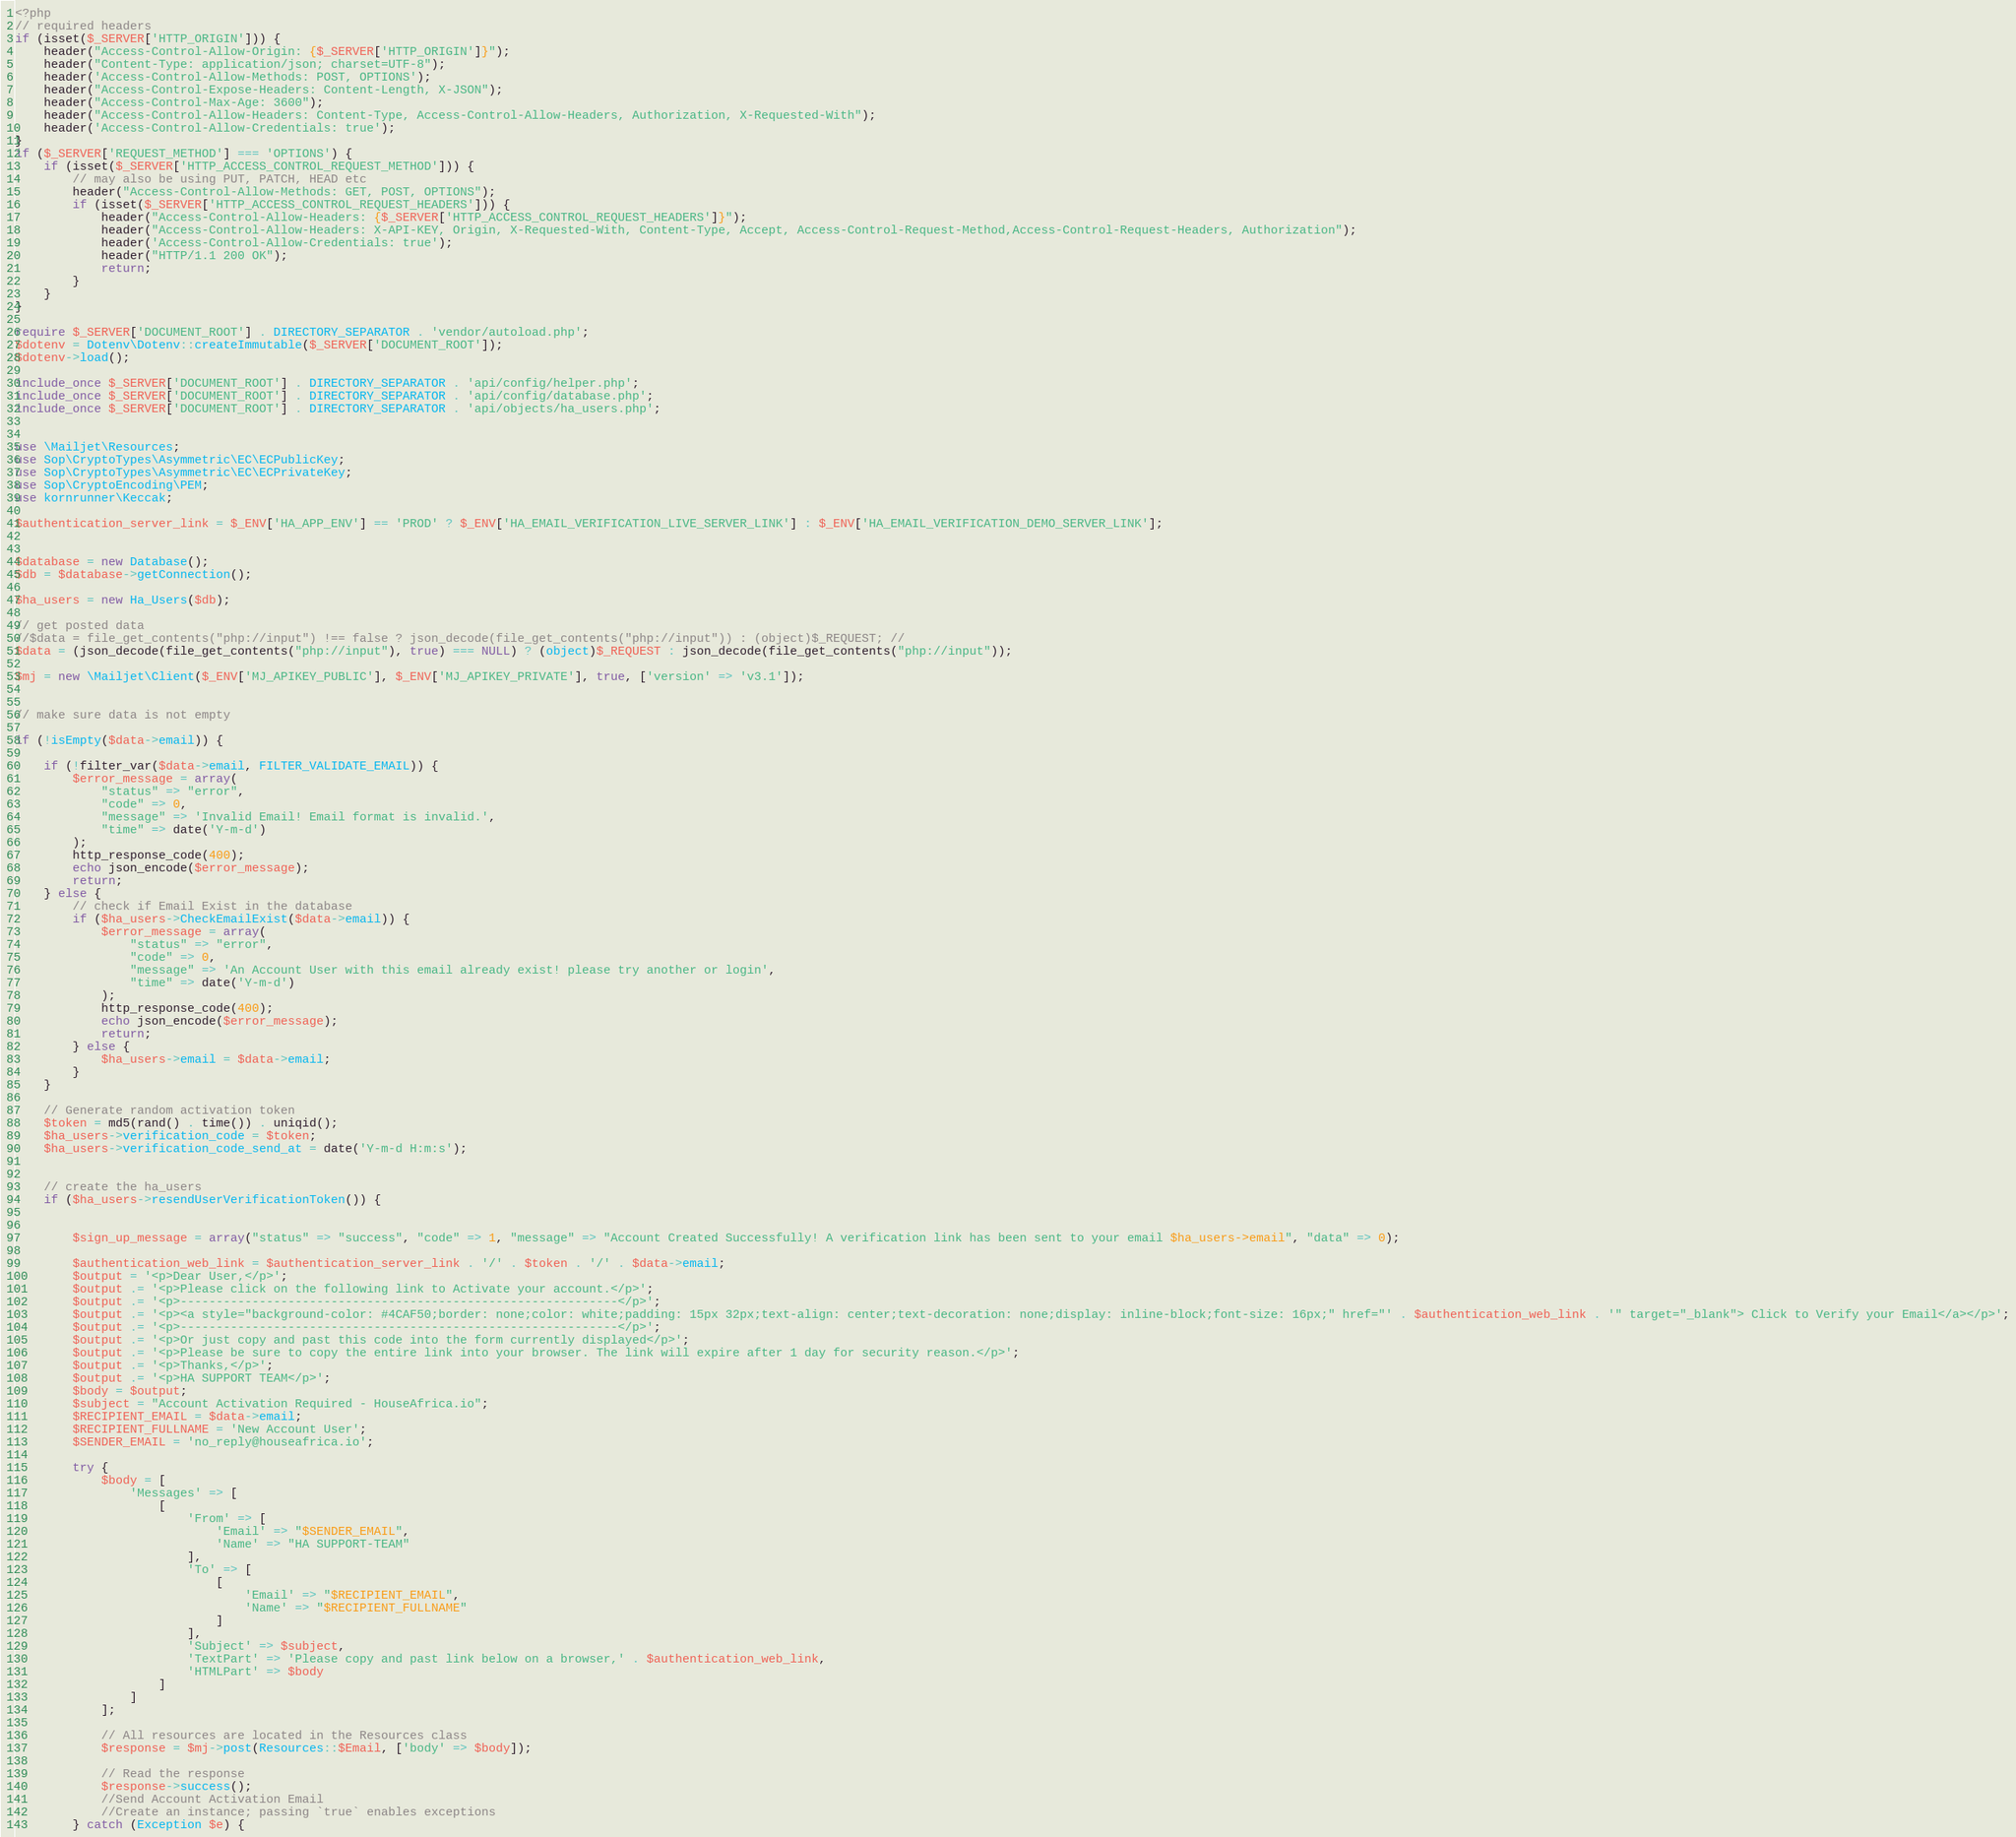Convert code to text. <code><loc_0><loc_0><loc_500><loc_500><_PHP_><?php
// required headers
if (isset($_SERVER['HTTP_ORIGIN'])) {
    header("Access-Control-Allow-Origin: {$_SERVER['HTTP_ORIGIN']}");
    header("Content-Type: application/json; charset=UTF-8");
    header('Access-Control-Allow-Methods: POST, OPTIONS');
    header("Access-Control-Expose-Headers: Content-Length, X-JSON");
    header("Access-Control-Max-Age: 3600");
    header("Access-Control-Allow-Headers: Content-Type, Access-Control-Allow-Headers, Authorization, X-Requested-With");
    header('Access-Control-Allow-Credentials: true');
}
if ($_SERVER['REQUEST_METHOD'] === 'OPTIONS') {
    if (isset($_SERVER['HTTP_ACCESS_CONTROL_REQUEST_METHOD'])) {
        // may also be using PUT, PATCH, HEAD etc
        header("Access-Control-Allow-Methods: GET, POST, OPTIONS");
        if (isset($_SERVER['HTTP_ACCESS_CONTROL_REQUEST_HEADERS'])) {
            header("Access-Control-Allow-Headers: {$_SERVER['HTTP_ACCESS_CONTROL_REQUEST_HEADERS']}");
            header("Access-Control-Allow-Headers: X-API-KEY, Origin, X-Requested-With, Content-Type, Accept, Access-Control-Request-Method,Access-Control-Request-Headers, Authorization");
            header('Access-Control-Allow-Credentials: true');
            header("HTTP/1.1 200 OK");
            return;
        }
    }
}

require $_SERVER['DOCUMENT_ROOT'] . DIRECTORY_SEPARATOR . 'vendor/autoload.php';
$dotenv = Dotenv\Dotenv::createImmutable($_SERVER['DOCUMENT_ROOT']);
$dotenv->load();

include_once $_SERVER['DOCUMENT_ROOT'] . DIRECTORY_SEPARATOR . 'api/config/helper.php';
include_once $_SERVER['DOCUMENT_ROOT'] . DIRECTORY_SEPARATOR . 'api/config/database.php';
include_once $_SERVER['DOCUMENT_ROOT'] . DIRECTORY_SEPARATOR . 'api/objects/ha_users.php';


use \Mailjet\Resources;
use Sop\CryptoTypes\Asymmetric\EC\ECPublicKey;
use Sop\CryptoTypes\Asymmetric\EC\ECPrivateKey;
use Sop\CryptoEncoding\PEM;
use kornrunner\Keccak;

$authentication_server_link = $_ENV['HA_APP_ENV'] == 'PROD' ? $_ENV['HA_EMAIL_VERIFICATION_LIVE_SERVER_LINK'] : $_ENV['HA_EMAIL_VERIFICATION_DEMO_SERVER_LINK'];


$database = new Database();
$db = $database->getConnection();

$ha_users = new Ha_Users($db);

// get posted data
//$data = file_get_contents("php://input") !== false ? json_decode(file_get_contents("php://input")) : (object)$_REQUEST; //
$data = (json_decode(file_get_contents("php://input"), true) === NULL) ? (object)$_REQUEST : json_decode(file_get_contents("php://input"));

$mj = new \Mailjet\Client($_ENV['MJ_APIKEY_PUBLIC'], $_ENV['MJ_APIKEY_PRIVATE'], true, ['version' => 'v3.1']);


// make sure data is not empty

if (!isEmpty($data->email)) {

    if (!filter_var($data->email, FILTER_VALIDATE_EMAIL)) {
        $error_message = array(
            "status" => "error",
            "code" => 0,
            "message" => 'Invalid Email! Email format is invalid.',
            "time" => date('Y-m-d')
        );
        http_response_code(400);
        echo json_encode($error_message);
        return;
    } else {
        // check if Email Exist in the database
        if ($ha_users->CheckEmailExist($data->email)) {
            $error_message = array(
                "status" => "error",
                "code" => 0,
                "message" => 'An Account User with this email already exist! please try another or login',
                "time" => date('Y-m-d')
            );
            http_response_code(400);
            echo json_encode($error_message);
            return;
        } else {
            $ha_users->email = $data->email;
        }
    }

    // Generate random activation token
    $token = md5(rand() . time()) . uniqid();
    $ha_users->verification_code = $token;
    $ha_users->verification_code_send_at = date('Y-m-d H:m:s');


    // create the ha_users
    if ($ha_users->resendUserVerificationToken()) {


        $sign_up_message = array("status" => "success", "code" => 1, "message" => "Account Created Successfully! A verification link has been sent to your email $ha_users->email", "data" => 0);

        $authentication_web_link = $authentication_server_link . '/' . $token . '/' . $data->email;
        $output = '<p>Dear User,</p>';
        $output .= '<p>Please click on the following link to Activate your account.</p>';
        $output .= '<p>-------------------------------------------------------------</p>';
        $output .= '<p><a style="background-color: #4CAF50;border: none;color: white;padding: 15px 32px;text-align: center;text-decoration: none;display: inline-block;font-size: 16px;" href="' . $authentication_web_link . '" target="_blank"> Click to Verify your Email</a></p>';
        $output .= '<p>-------------------------------------------------------------</p>';
        $output .= '<p>Or just copy and past this code into the form currently displayed</p>';
        $output .= '<p>Please be sure to copy the entire link into your browser. The link will expire after 1 day for security reason.</p>';
        $output .= '<p>Thanks,</p>';
        $output .= '<p>HA SUPPORT TEAM</p>';
        $body = $output;
        $subject = "Account Activation Required - HouseAfrica.io";
        $RECIPIENT_EMAIL = $data->email;
        $RECIPIENT_FULLNAME = 'New Account User';
        $SENDER_EMAIL = 'no_reply@houseafrica.io';

        try {
            $body = [
                'Messages' => [
                    [
                        'From' => [
                            'Email' => "$SENDER_EMAIL",
                            'Name' => "HA SUPPORT-TEAM"
                        ],
                        'To' => [
                            [
                                'Email' => "$RECIPIENT_EMAIL",
                                'Name' => "$RECIPIENT_FULLNAME"
                            ]
                        ],
                        'Subject' => $subject,
                        'TextPart' => 'Please copy and past link below on a browser,' . $authentication_web_link,
                        'HTMLPart' => $body
                    ]
                ]
            ];

            // All resources are located in the Resources class
            $response = $mj->post(Resources::$Email, ['body' => $body]);

            // Read the response
            $response->success();
            //Send Account Activation Email
            //Create an instance; passing `true` enables exceptions
        } catch (Exception $e) {</code> 